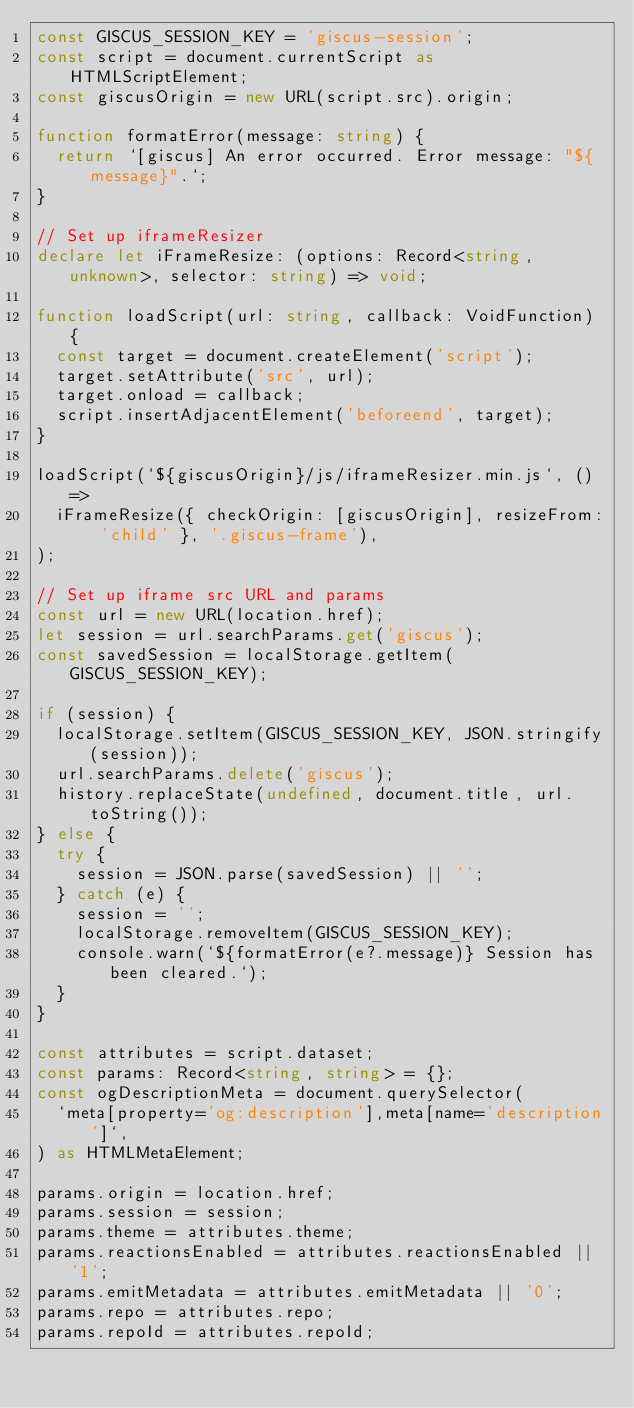<code> <loc_0><loc_0><loc_500><loc_500><_TypeScript_>const GISCUS_SESSION_KEY = 'giscus-session';
const script = document.currentScript as HTMLScriptElement;
const giscusOrigin = new URL(script.src).origin;

function formatError(message: string) {
  return `[giscus] An error occurred. Error message: "${message}".`;
}

// Set up iframeResizer
declare let iFrameResize: (options: Record<string, unknown>, selector: string) => void;

function loadScript(url: string, callback: VoidFunction) {
  const target = document.createElement('script');
  target.setAttribute('src', url);
  target.onload = callback;
  script.insertAdjacentElement('beforeend', target);
}

loadScript(`${giscusOrigin}/js/iframeResizer.min.js`, () =>
  iFrameResize({ checkOrigin: [giscusOrigin], resizeFrom: 'child' }, '.giscus-frame'),
);

// Set up iframe src URL and params
const url = new URL(location.href);
let session = url.searchParams.get('giscus');
const savedSession = localStorage.getItem(GISCUS_SESSION_KEY);

if (session) {
  localStorage.setItem(GISCUS_SESSION_KEY, JSON.stringify(session));
  url.searchParams.delete('giscus');
  history.replaceState(undefined, document.title, url.toString());
} else {
  try {
    session = JSON.parse(savedSession) || '';
  } catch (e) {
    session = '';
    localStorage.removeItem(GISCUS_SESSION_KEY);
    console.warn(`${formatError(e?.message)} Session has been cleared.`);
  }
}

const attributes = script.dataset;
const params: Record<string, string> = {};
const ogDescriptionMeta = document.querySelector(
  `meta[property='og:description'],meta[name='description']`,
) as HTMLMetaElement;

params.origin = location.href;
params.session = session;
params.theme = attributes.theme;
params.reactionsEnabled = attributes.reactionsEnabled || '1';
params.emitMetadata = attributes.emitMetadata || '0';
params.repo = attributes.repo;
params.repoId = attributes.repoId;</code> 